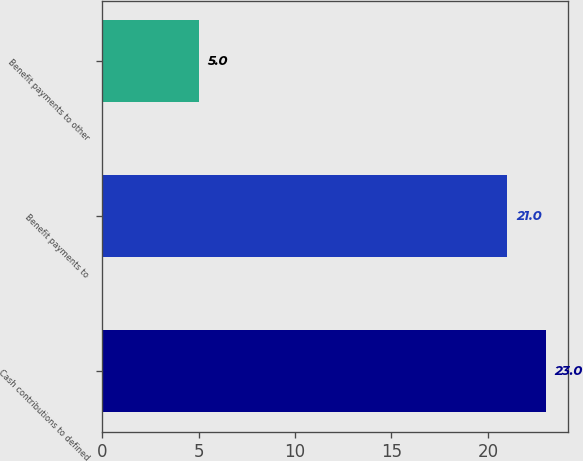Convert chart to OTSL. <chart><loc_0><loc_0><loc_500><loc_500><bar_chart><fcel>Cash contributions to defined<fcel>Benefit payments to<fcel>Benefit payments to other<nl><fcel>23<fcel>21<fcel>5<nl></chart> 